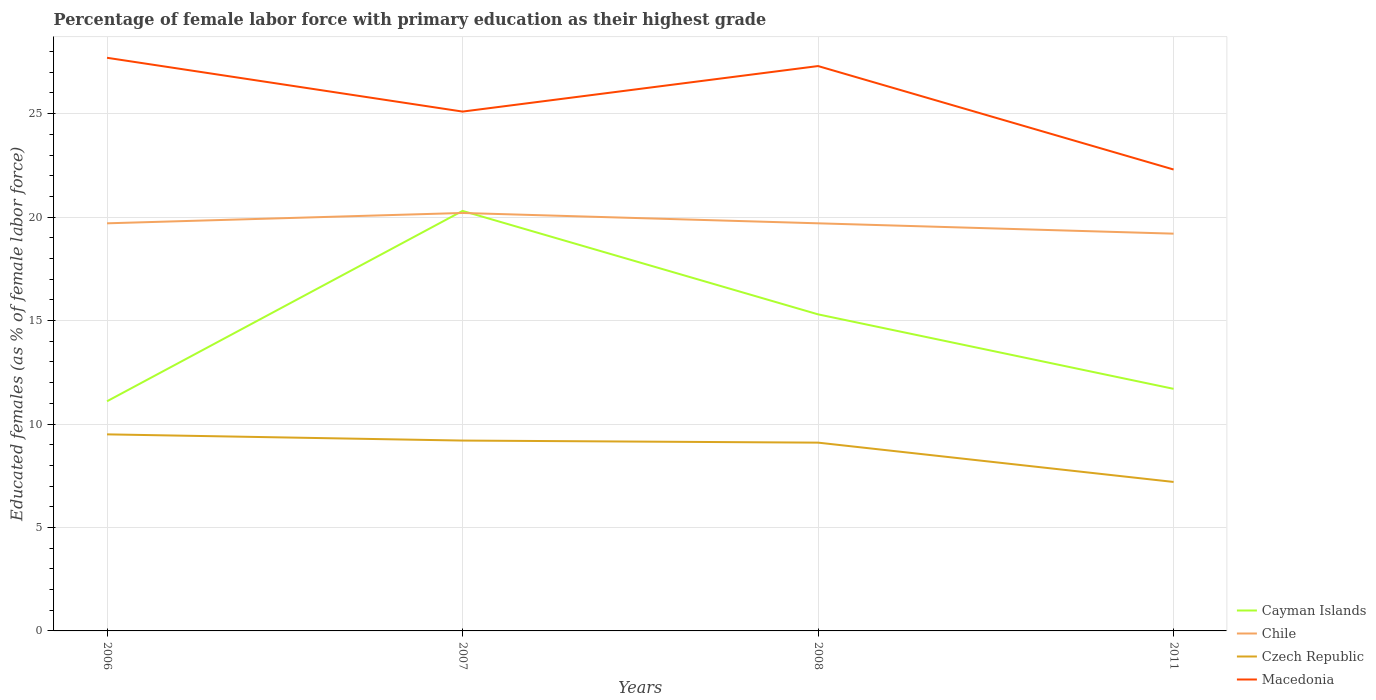How many different coloured lines are there?
Offer a terse response. 4. Is the number of lines equal to the number of legend labels?
Offer a terse response. Yes. Across all years, what is the maximum percentage of female labor force with primary education in Chile?
Your response must be concise. 19.2. In which year was the percentage of female labor force with primary education in Macedonia maximum?
Make the answer very short. 2011. What is the difference between the highest and the second highest percentage of female labor force with primary education in Czech Republic?
Keep it short and to the point. 2.3. Is the percentage of female labor force with primary education in Chile strictly greater than the percentage of female labor force with primary education in Czech Republic over the years?
Your response must be concise. No. How many lines are there?
Offer a terse response. 4. What is the difference between two consecutive major ticks on the Y-axis?
Ensure brevity in your answer.  5. Are the values on the major ticks of Y-axis written in scientific E-notation?
Make the answer very short. No. Where does the legend appear in the graph?
Provide a succinct answer. Bottom right. How many legend labels are there?
Offer a terse response. 4. What is the title of the graph?
Your answer should be very brief. Percentage of female labor force with primary education as their highest grade. Does "Tonga" appear as one of the legend labels in the graph?
Ensure brevity in your answer.  No. What is the label or title of the Y-axis?
Provide a short and direct response. Educated females (as % of female labor force). What is the Educated females (as % of female labor force) in Cayman Islands in 2006?
Ensure brevity in your answer.  11.1. What is the Educated females (as % of female labor force) of Chile in 2006?
Provide a short and direct response. 19.7. What is the Educated females (as % of female labor force) of Czech Republic in 2006?
Ensure brevity in your answer.  9.5. What is the Educated females (as % of female labor force) of Macedonia in 2006?
Your answer should be compact. 27.7. What is the Educated females (as % of female labor force) of Cayman Islands in 2007?
Your answer should be compact. 20.3. What is the Educated females (as % of female labor force) in Chile in 2007?
Provide a short and direct response. 20.2. What is the Educated females (as % of female labor force) of Czech Republic in 2007?
Offer a very short reply. 9.2. What is the Educated females (as % of female labor force) of Macedonia in 2007?
Your answer should be very brief. 25.1. What is the Educated females (as % of female labor force) of Cayman Islands in 2008?
Your response must be concise. 15.3. What is the Educated females (as % of female labor force) of Chile in 2008?
Your answer should be very brief. 19.7. What is the Educated females (as % of female labor force) of Czech Republic in 2008?
Make the answer very short. 9.1. What is the Educated females (as % of female labor force) in Macedonia in 2008?
Your answer should be very brief. 27.3. What is the Educated females (as % of female labor force) in Cayman Islands in 2011?
Your response must be concise. 11.7. What is the Educated females (as % of female labor force) of Chile in 2011?
Make the answer very short. 19.2. What is the Educated females (as % of female labor force) of Czech Republic in 2011?
Provide a short and direct response. 7.2. What is the Educated females (as % of female labor force) in Macedonia in 2011?
Your answer should be very brief. 22.3. Across all years, what is the maximum Educated females (as % of female labor force) in Cayman Islands?
Your response must be concise. 20.3. Across all years, what is the maximum Educated females (as % of female labor force) in Chile?
Ensure brevity in your answer.  20.2. Across all years, what is the maximum Educated females (as % of female labor force) in Czech Republic?
Your response must be concise. 9.5. Across all years, what is the maximum Educated females (as % of female labor force) in Macedonia?
Keep it short and to the point. 27.7. Across all years, what is the minimum Educated females (as % of female labor force) in Cayman Islands?
Make the answer very short. 11.1. Across all years, what is the minimum Educated females (as % of female labor force) of Chile?
Your answer should be very brief. 19.2. Across all years, what is the minimum Educated females (as % of female labor force) in Czech Republic?
Make the answer very short. 7.2. Across all years, what is the minimum Educated females (as % of female labor force) in Macedonia?
Your answer should be compact. 22.3. What is the total Educated females (as % of female labor force) in Cayman Islands in the graph?
Give a very brief answer. 58.4. What is the total Educated females (as % of female labor force) in Chile in the graph?
Your response must be concise. 78.8. What is the total Educated females (as % of female labor force) in Macedonia in the graph?
Offer a terse response. 102.4. What is the difference between the Educated females (as % of female labor force) of Cayman Islands in 2006 and that in 2007?
Provide a succinct answer. -9.2. What is the difference between the Educated females (as % of female labor force) of Czech Republic in 2006 and that in 2007?
Your answer should be very brief. 0.3. What is the difference between the Educated females (as % of female labor force) of Cayman Islands in 2006 and that in 2008?
Provide a succinct answer. -4.2. What is the difference between the Educated females (as % of female labor force) in Chile in 2006 and that in 2008?
Your response must be concise. 0. What is the difference between the Educated females (as % of female labor force) in Macedonia in 2006 and that in 2008?
Make the answer very short. 0.4. What is the difference between the Educated females (as % of female labor force) of Chile in 2006 and that in 2011?
Ensure brevity in your answer.  0.5. What is the difference between the Educated females (as % of female labor force) of Cayman Islands in 2007 and that in 2008?
Provide a short and direct response. 5. What is the difference between the Educated females (as % of female labor force) in Czech Republic in 2007 and that in 2008?
Provide a succinct answer. 0.1. What is the difference between the Educated females (as % of female labor force) of Macedonia in 2007 and that in 2008?
Make the answer very short. -2.2. What is the difference between the Educated females (as % of female labor force) of Chile in 2007 and that in 2011?
Your answer should be very brief. 1. What is the difference between the Educated females (as % of female labor force) of Czech Republic in 2007 and that in 2011?
Give a very brief answer. 2. What is the difference between the Educated females (as % of female labor force) in Chile in 2008 and that in 2011?
Provide a succinct answer. 0.5. What is the difference between the Educated females (as % of female labor force) in Cayman Islands in 2006 and the Educated females (as % of female labor force) in Czech Republic in 2007?
Give a very brief answer. 1.9. What is the difference between the Educated females (as % of female labor force) in Cayman Islands in 2006 and the Educated females (as % of female labor force) in Macedonia in 2007?
Your answer should be very brief. -14. What is the difference between the Educated females (as % of female labor force) in Chile in 2006 and the Educated females (as % of female labor force) in Macedonia in 2007?
Provide a succinct answer. -5.4. What is the difference between the Educated females (as % of female labor force) in Czech Republic in 2006 and the Educated females (as % of female labor force) in Macedonia in 2007?
Offer a terse response. -15.6. What is the difference between the Educated females (as % of female labor force) in Cayman Islands in 2006 and the Educated females (as % of female labor force) in Macedonia in 2008?
Provide a short and direct response. -16.2. What is the difference between the Educated females (as % of female labor force) of Chile in 2006 and the Educated females (as % of female labor force) of Macedonia in 2008?
Give a very brief answer. -7.6. What is the difference between the Educated females (as % of female labor force) in Czech Republic in 2006 and the Educated females (as % of female labor force) in Macedonia in 2008?
Your response must be concise. -17.8. What is the difference between the Educated females (as % of female labor force) of Cayman Islands in 2006 and the Educated females (as % of female labor force) of Czech Republic in 2011?
Ensure brevity in your answer.  3.9. What is the difference between the Educated females (as % of female labor force) of Cayman Islands in 2006 and the Educated females (as % of female labor force) of Macedonia in 2011?
Offer a very short reply. -11.2. What is the difference between the Educated females (as % of female labor force) of Cayman Islands in 2007 and the Educated females (as % of female labor force) of Czech Republic in 2008?
Your response must be concise. 11.2. What is the difference between the Educated females (as % of female labor force) of Cayman Islands in 2007 and the Educated females (as % of female labor force) of Macedonia in 2008?
Your answer should be compact. -7. What is the difference between the Educated females (as % of female labor force) of Chile in 2007 and the Educated females (as % of female labor force) of Czech Republic in 2008?
Your answer should be very brief. 11.1. What is the difference between the Educated females (as % of female labor force) of Chile in 2007 and the Educated females (as % of female labor force) of Macedonia in 2008?
Your answer should be compact. -7.1. What is the difference between the Educated females (as % of female labor force) in Czech Republic in 2007 and the Educated females (as % of female labor force) in Macedonia in 2008?
Keep it short and to the point. -18.1. What is the difference between the Educated females (as % of female labor force) in Cayman Islands in 2007 and the Educated females (as % of female labor force) in Chile in 2011?
Offer a very short reply. 1.1. What is the difference between the Educated females (as % of female labor force) of Cayman Islands in 2007 and the Educated females (as % of female labor force) of Czech Republic in 2011?
Keep it short and to the point. 13.1. What is the difference between the Educated females (as % of female labor force) of Cayman Islands in 2007 and the Educated females (as % of female labor force) of Macedonia in 2011?
Your answer should be compact. -2. What is the difference between the Educated females (as % of female labor force) of Chile in 2007 and the Educated females (as % of female labor force) of Macedonia in 2011?
Provide a succinct answer. -2.1. What is the difference between the Educated females (as % of female labor force) of Cayman Islands in 2008 and the Educated females (as % of female labor force) of Macedonia in 2011?
Your response must be concise. -7. What is the difference between the Educated females (as % of female labor force) of Chile in 2008 and the Educated females (as % of female labor force) of Macedonia in 2011?
Your answer should be compact. -2.6. What is the average Educated females (as % of female labor force) of Chile per year?
Make the answer very short. 19.7. What is the average Educated females (as % of female labor force) of Czech Republic per year?
Make the answer very short. 8.75. What is the average Educated females (as % of female labor force) of Macedonia per year?
Offer a very short reply. 25.6. In the year 2006, what is the difference between the Educated females (as % of female labor force) of Cayman Islands and Educated females (as % of female labor force) of Czech Republic?
Give a very brief answer. 1.6. In the year 2006, what is the difference between the Educated females (as % of female labor force) of Cayman Islands and Educated females (as % of female labor force) of Macedonia?
Offer a very short reply. -16.6. In the year 2006, what is the difference between the Educated females (as % of female labor force) of Czech Republic and Educated females (as % of female labor force) of Macedonia?
Provide a succinct answer. -18.2. In the year 2007, what is the difference between the Educated females (as % of female labor force) in Cayman Islands and Educated females (as % of female labor force) in Macedonia?
Your answer should be compact. -4.8. In the year 2007, what is the difference between the Educated females (as % of female labor force) in Chile and Educated females (as % of female labor force) in Czech Republic?
Your answer should be very brief. 11. In the year 2007, what is the difference between the Educated females (as % of female labor force) of Czech Republic and Educated females (as % of female labor force) of Macedonia?
Offer a very short reply. -15.9. In the year 2008, what is the difference between the Educated females (as % of female labor force) of Cayman Islands and Educated females (as % of female labor force) of Czech Republic?
Make the answer very short. 6.2. In the year 2008, what is the difference between the Educated females (as % of female labor force) in Czech Republic and Educated females (as % of female labor force) in Macedonia?
Ensure brevity in your answer.  -18.2. In the year 2011, what is the difference between the Educated females (as % of female labor force) of Cayman Islands and Educated females (as % of female labor force) of Chile?
Give a very brief answer. -7.5. In the year 2011, what is the difference between the Educated females (as % of female labor force) of Cayman Islands and Educated females (as % of female labor force) of Czech Republic?
Give a very brief answer. 4.5. In the year 2011, what is the difference between the Educated females (as % of female labor force) in Cayman Islands and Educated females (as % of female labor force) in Macedonia?
Your response must be concise. -10.6. In the year 2011, what is the difference between the Educated females (as % of female labor force) in Chile and Educated females (as % of female labor force) in Czech Republic?
Give a very brief answer. 12. In the year 2011, what is the difference between the Educated females (as % of female labor force) in Chile and Educated females (as % of female labor force) in Macedonia?
Provide a succinct answer. -3.1. In the year 2011, what is the difference between the Educated females (as % of female labor force) of Czech Republic and Educated females (as % of female labor force) of Macedonia?
Your response must be concise. -15.1. What is the ratio of the Educated females (as % of female labor force) of Cayman Islands in 2006 to that in 2007?
Ensure brevity in your answer.  0.55. What is the ratio of the Educated females (as % of female labor force) in Chile in 2006 to that in 2007?
Provide a succinct answer. 0.98. What is the ratio of the Educated females (as % of female labor force) of Czech Republic in 2006 to that in 2007?
Your response must be concise. 1.03. What is the ratio of the Educated females (as % of female labor force) of Macedonia in 2006 to that in 2007?
Your response must be concise. 1.1. What is the ratio of the Educated females (as % of female labor force) in Cayman Islands in 2006 to that in 2008?
Your answer should be very brief. 0.73. What is the ratio of the Educated females (as % of female labor force) in Chile in 2006 to that in 2008?
Your answer should be compact. 1. What is the ratio of the Educated females (as % of female labor force) of Czech Republic in 2006 to that in 2008?
Your answer should be very brief. 1.04. What is the ratio of the Educated females (as % of female labor force) in Macedonia in 2006 to that in 2008?
Ensure brevity in your answer.  1.01. What is the ratio of the Educated females (as % of female labor force) in Cayman Islands in 2006 to that in 2011?
Ensure brevity in your answer.  0.95. What is the ratio of the Educated females (as % of female labor force) in Chile in 2006 to that in 2011?
Provide a short and direct response. 1.03. What is the ratio of the Educated females (as % of female labor force) of Czech Republic in 2006 to that in 2011?
Keep it short and to the point. 1.32. What is the ratio of the Educated females (as % of female labor force) of Macedonia in 2006 to that in 2011?
Offer a very short reply. 1.24. What is the ratio of the Educated females (as % of female labor force) of Cayman Islands in 2007 to that in 2008?
Keep it short and to the point. 1.33. What is the ratio of the Educated females (as % of female labor force) in Chile in 2007 to that in 2008?
Your response must be concise. 1.03. What is the ratio of the Educated females (as % of female labor force) of Czech Republic in 2007 to that in 2008?
Your answer should be very brief. 1.01. What is the ratio of the Educated females (as % of female labor force) in Macedonia in 2007 to that in 2008?
Offer a very short reply. 0.92. What is the ratio of the Educated females (as % of female labor force) of Cayman Islands in 2007 to that in 2011?
Your answer should be very brief. 1.74. What is the ratio of the Educated females (as % of female labor force) of Chile in 2007 to that in 2011?
Provide a short and direct response. 1.05. What is the ratio of the Educated females (as % of female labor force) in Czech Republic in 2007 to that in 2011?
Make the answer very short. 1.28. What is the ratio of the Educated females (as % of female labor force) of Macedonia in 2007 to that in 2011?
Your answer should be very brief. 1.13. What is the ratio of the Educated females (as % of female labor force) of Cayman Islands in 2008 to that in 2011?
Your answer should be very brief. 1.31. What is the ratio of the Educated females (as % of female labor force) in Czech Republic in 2008 to that in 2011?
Keep it short and to the point. 1.26. What is the ratio of the Educated females (as % of female labor force) in Macedonia in 2008 to that in 2011?
Offer a very short reply. 1.22. What is the difference between the highest and the second highest Educated females (as % of female labor force) of Cayman Islands?
Offer a terse response. 5. What is the difference between the highest and the second highest Educated females (as % of female labor force) in Chile?
Offer a terse response. 0.5. What is the difference between the highest and the second highest Educated females (as % of female labor force) in Czech Republic?
Your answer should be compact. 0.3. What is the difference between the highest and the lowest Educated females (as % of female labor force) in Macedonia?
Your response must be concise. 5.4. 